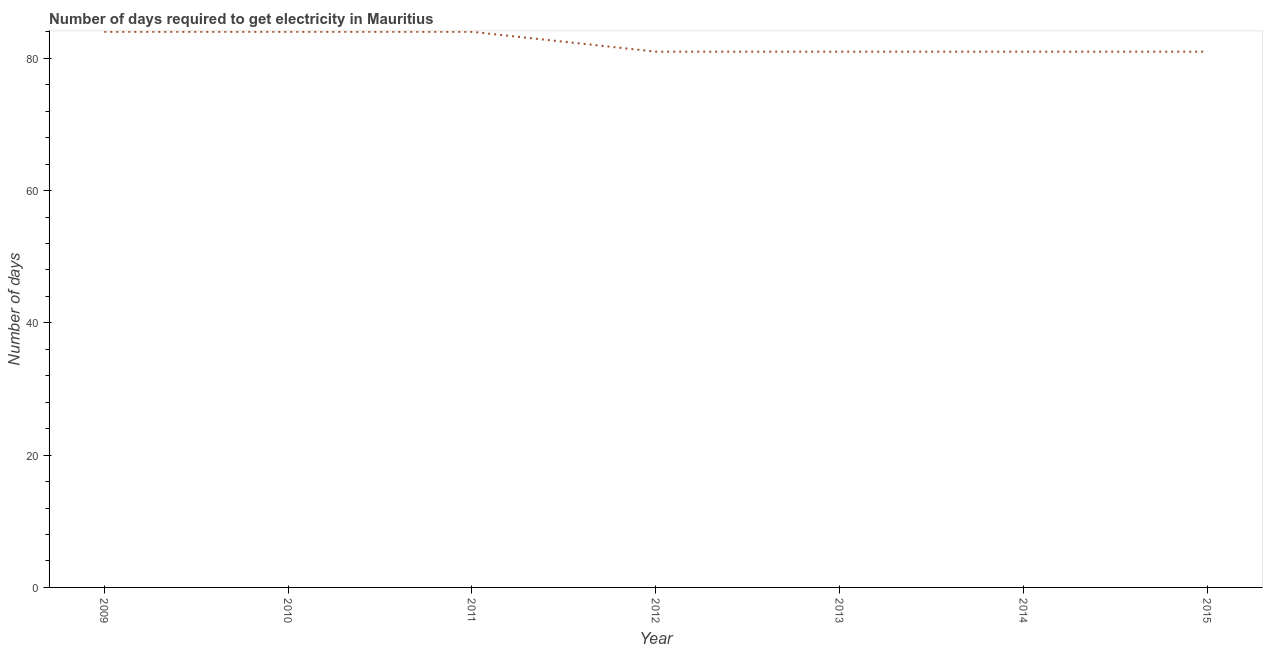What is the time to get electricity in 2009?
Offer a very short reply. 84. Across all years, what is the maximum time to get electricity?
Your answer should be compact. 84. Across all years, what is the minimum time to get electricity?
Ensure brevity in your answer.  81. In which year was the time to get electricity maximum?
Keep it short and to the point. 2009. In which year was the time to get electricity minimum?
Your answer should be compact. 2012. What is the sum of the time to get electricity?
Ensure brevity in your answer.  576. What is the difference between the time to get electricity in 2009 and 2013?
Make the answer very short. 3. What is the average time to get electricity per year?
Keep it short and to the point. 82.29. What is the median time to get electricity?
Your response must be concise. 81. In how many years, is the time to get electricity greater than 60 ?
Offer a terse response. 7. Is the time to get electricity in 2009 less than that in 2014?
Keep it short and to the point. No. Is the difference between the time to get electricity in 2009 and 2015 greater than the difference between any two years?
Your answer should be compact. Yes. What is the difference between the highest and the second highest time to get electricity?
Give a very brief answer. 0. What is the difference between the highest and the lowest time to get electricity?
Keep it short and to the point. 3. Does the time to get electricity monotonically increase over the years?
Your answer should be very brief. No. Are the values on the major ticks of Y-axis written in scientific E-notation?
Offer a very short reply. No. Does the graph contain grids?
Your answer should be compact. No. What is the title of the graph?
Provide a succinct answer. Number of days required to get electricity in Mauritius. What is the label or title of the Y-axis?
Offer a terse response. Number of days. What is the Number of days in 2010?
Your answer should be very brief. 84. What is the Number of days in 2011?
Provide a succinct answer. 84. What is the Number of days in 2013?
Offer a terse response. 81. What is the Number of days in 2014?
Provide a short and direct response. 81. What is the Number of days of 2015?
Make the answer very short. 81. What is the difference between the Number of days in 2009 and 2013?
Keep it short and to the point. 3. What is the difference between the Number of days in 2010 and 2011?
Provide a succinct answer. 0. What is the difference between the Number of days in 2010 and 2013?
Make the answer very short. 3. What is the difference between the Number of days in 2010 and 2014?
Offer a terse response. 3. What is the difference between the Number of days in 2010 and 2015?
Your answer should be very brief. 3. What is the difference between the Number of days in 2011 and 2013?
Give a very brief answer. 3. What is the difference between the Number of days in 2011 and 2014?
Keep it short and to the point. 3. What is the difference between the Number of days in 2012 and 2013?
Keep it short and to the point. 0. What is the difference between the Number of days in 2012 and 2015?
Provide a short and direct response. 0. What is the difference between the Number of days in 2013 and 2015?
Ensure brevity in your answer.  0. What is the ratio of the Number of days in 2009 to that in 2010?
Provide a succinct answer. 1. What is the ratio of the Number of days in 2009 to that in 2015?
Your answer should be very brief. 1.04. What is the ratio of the Number of days in 2010 to that in 2011?
Provide a succinct answer. 1. What is the ratio of the Number of days in 2010 to that in 2015?
Provide a short and direct response. 1.04. What is the ratio of the Number of days in 2011 to that in 2013?
Provide a succinct answer. 1.04. What is the ratio of the Number of days in 2011 to that in 2014?
Your response must be concise. 1.04. What is the ratio of the Number of days in 2012 to that in 2013?
Give a very brief answer. 1. What is the ratio of the Number of days in 2012 to that in 2014?
Give a very brief answer. 1. What is the ratio of the Number of days in 2013 to that in 2014?
Your response must be concise. 1. What is the ratio of the Number of days in 2013 to that in 2015?
Offer a terse response. 1. 